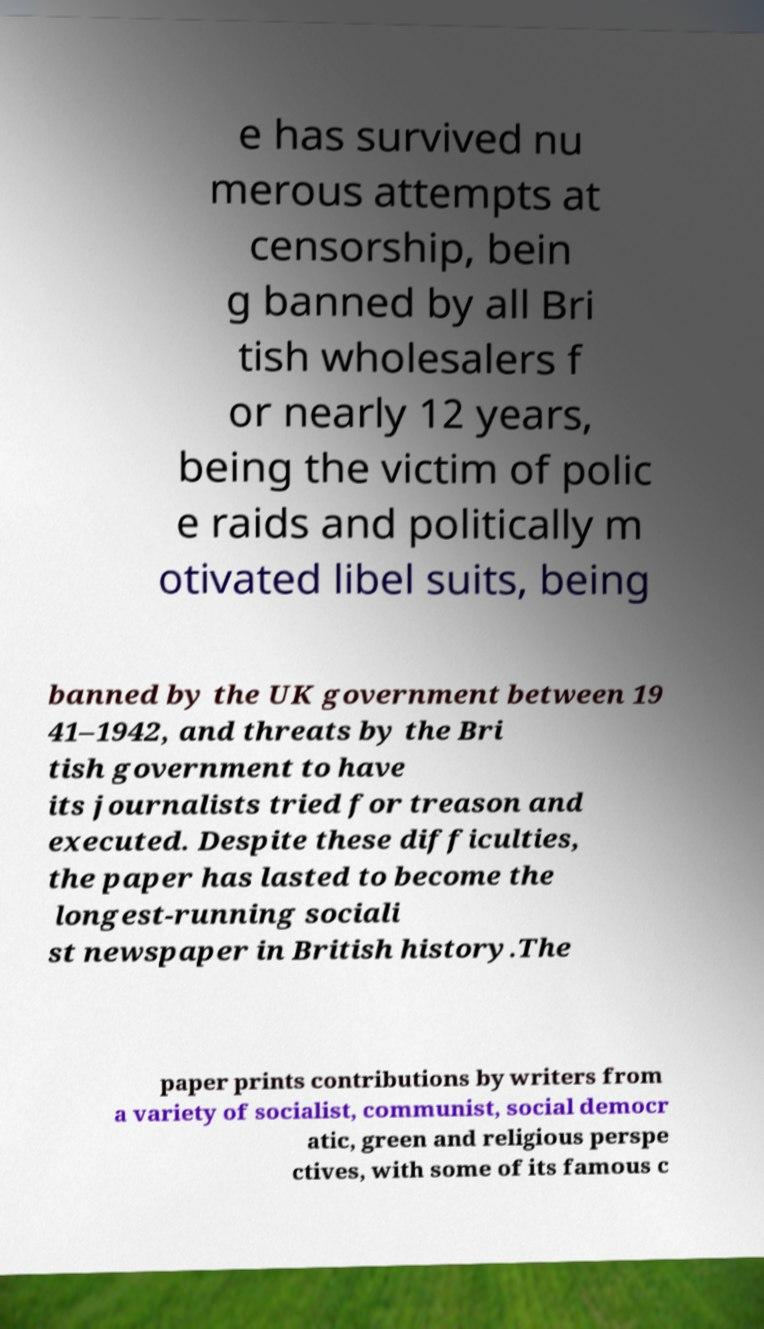What messages or text are displayed in this image? I need them in a readable, typed format. e has survived nu merous attempts at censorship, bein g banned by all Bri tish wholesalers f or nearly 12 years, being the victim of polic e raids and politically m otivated libel suits, being banned by the UK government between 19 41–1942, and threats by the Bri tish government to have its journalists tried for treason and executed. Despite these difficulties, the paper has lasted to become the longest-running sociali st newspaper in British history.The paper prints contributions by writers from a variety of socialist, communist, social democr atic, green and religious perspe ctives, with some of its famous c 